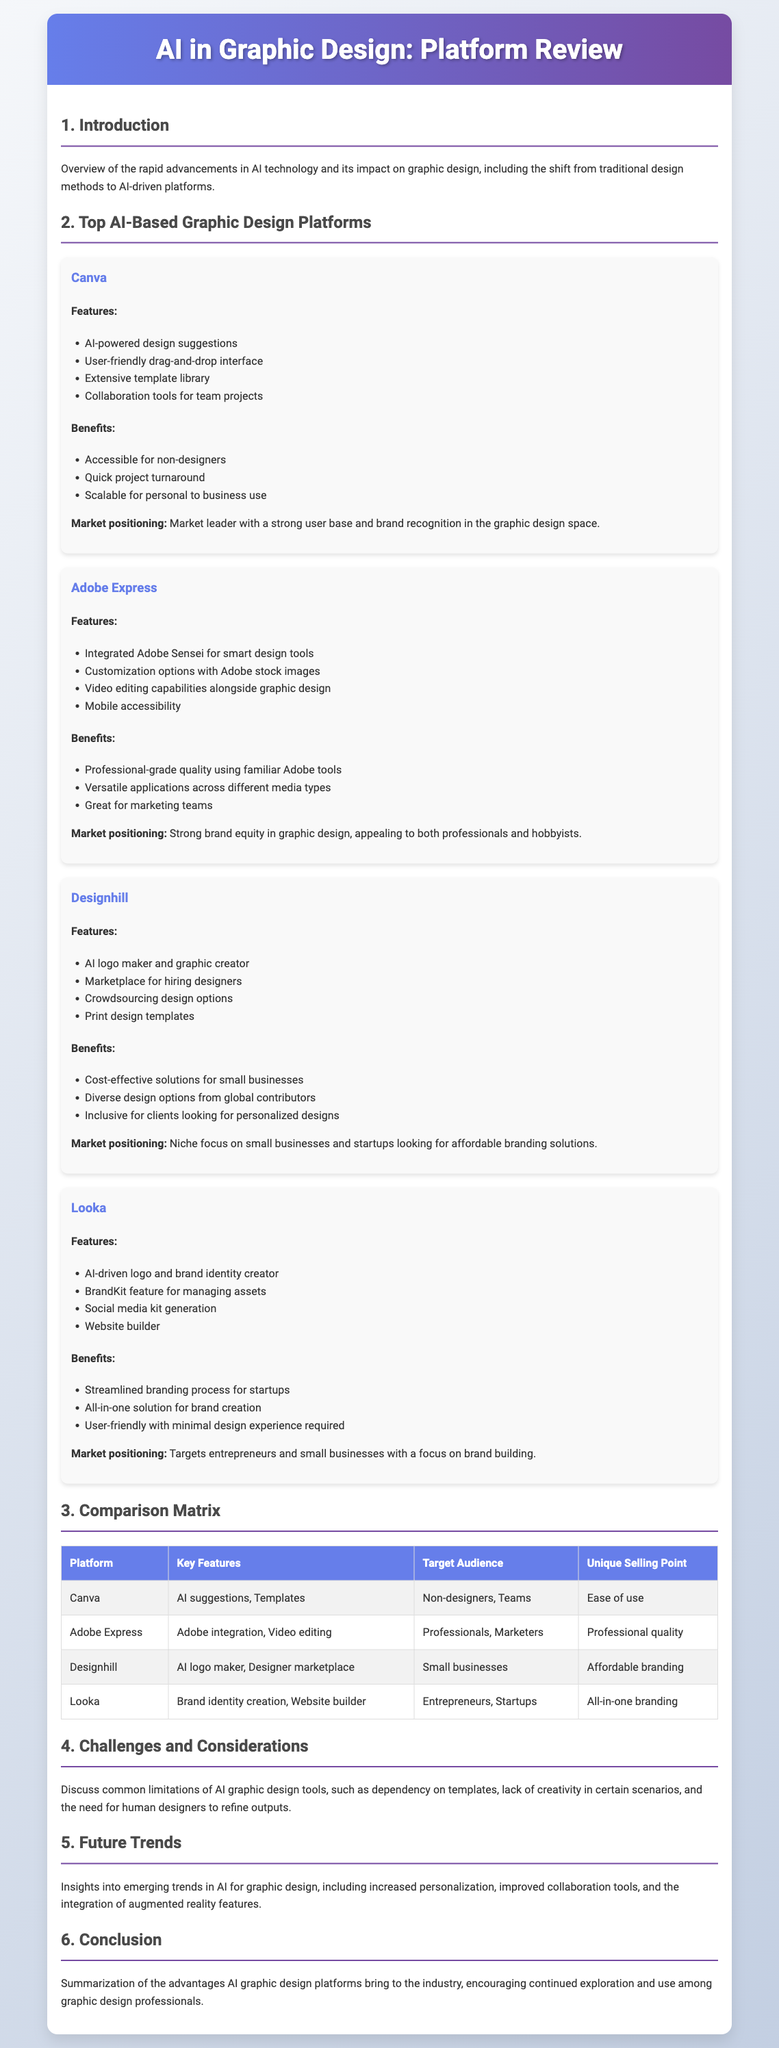What is the first platform reviewed? The document lists the first platform reviewed in the section about top AI-based graphic design platforms.
Answer: Canva What feature does Adobe Express integrate with? Adobe Express integrates with Adobe Sensei for smart design tools.
Answer: Adobe Sensei Which platform focuses on small businesses? The document indicates a platform that is tailored to small businesses, highlighting its niche focus.
Answer: Designhill What is Looka’s unique selling point? Looka's unique selling point is summarized in the document, emphasizing its focus on brand building.
Answer: All-in-one branding How many platforms are discussed in the document? The number of platforms reviewed in the section is identifiable through a count of the distinct entries listed.
Answer: Four What benefit is highlighted for Canva users? One of the benefits mentioned for Canva users relates to accessibility and its ease of use for a specific demographic.
Answer: Accessible for non-designers What challenges are mentioned in the document regarding AI graphic design tools? The challenges surrounding AI graphic design tools are elaborated in a particular section of the document, referring to common limitations.
Answer: Dependency on templates What is a future trend mentioned for AI in graphic design? The document provides insights into an emerging trend related to advancements in the technology used in graphic design.
Answer: Increased personalization 